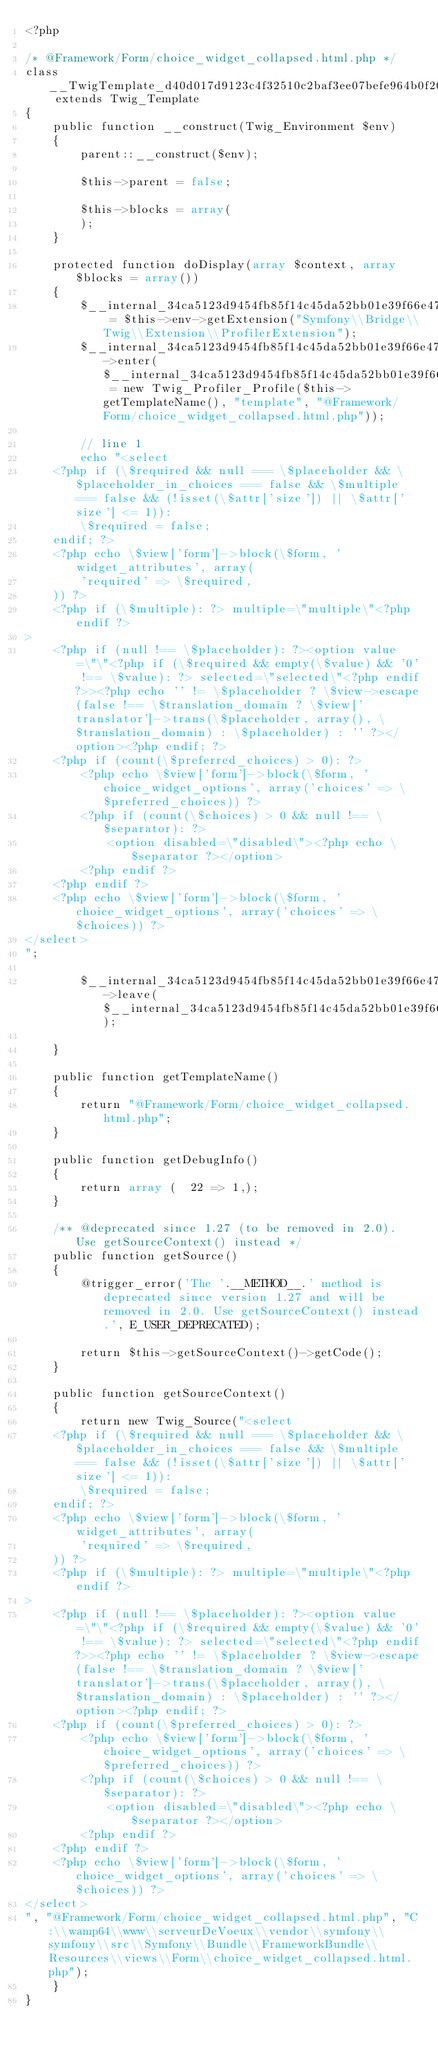<code> <loc_0><loc_0><loc_500><loc_500><_PHP_><?php

/* @Framework/Form/choice_widget_collapsed.html.php */
class __TwigTemplate_d40d017d9123c4f32510c2baf3ee07befe964b0f20a939435dd4f6bbbf2505c4 extends Twig_Template
{
    public function __construct(Twig_Environment $env)
    {
        parent::__construct($env);

        $this->parent = false;

        $this->blocks = array(
        );
    }

    protected function doDisplay(array $context, array $blocks = array())
    {
        $__internal_34ca5123d9454fb85f14c45da52bb01e39f66e478682ad9883562f83e0ccfe22 = $this->env->getExtension("Symfony\\Bridge\\Twig\\Extension\\ProfilerExtension");
        $__internal_34ca5123d9454fb85f14c45da52bb01e39f66e478682ad9883562f83e0ccfe22->enter($__internal_34ca5123d9454fb85f14c45da52bb01e39f66e478682ad9883562f83e0ccfe22_prof = new Twig_Profiler_Profile($this->getTemplateName(), "template", "@Framework/Form/choice_widget_collapsed.html.php"));

        // line 1
        echo "<select
    <?php if (\$required && null === \$placeholder && \$placeholder_in_choices === false && \$multiple === false && (!isset(\$attr['size']) || \$attr['size'] <= 1)):
        \$required = false;
    endif; ?>
    <?php echo \$view['form']->block(\$form, 'widget_attributes', array(
        'required' => \$required,
    )) ?>
    <?php if (\$multiple): ?> multiple=\"multiple\"<?php endif ?>
>
    <?php if (null !== \$placeholder): ?><option value=\"\"<?php if (\$required && empty(\$value) && '0' !== \$value): ?> selected=\"selected\"<?php endif?>><?php echo '' != \$placeholder ? \$view->escape(false !== \$translation_domain ? \$view['translator']->trans(\$placeholder, array(), \$translation_domain) : \$placeholder) : '' ?></option><?php endif; ?>
    <?php if (count(\$preferred_choices) > 0): ?>
        <?php echo \$view['form']->block(\$form, 'choice_widget_options', array('choices' => \$preferred_choices)) ?>
        <?php if (count(\$choices) > 0 && null !== \$separator): ?>
            <option disabled=\"disabled\"><?php echo \$separator ?></option>
        <?php endif ?>
    <?php endif ?>
    <?php echo \$view['form']->block(\$form, 'choice_widget_options', array('choices' => \$choices)) ?>
</select>
";
        
        $__internal_34ca5123d9454fb85f14c45da52bb01e39f66e478682ad9883562f83e0ccfe22->leave($__internal_34ca5123d9454fb85f14c45da52bb01e39f66e478682ad9883562f83e0ccfe22_prof);

    }

    public function getTemplateName()
    {
        return "@Framework/Form/choice_widget_collapsed.html.php";
    }

    public function getDebugInfo()
    {
        return array (  22 => 1,);
    }

    /** @deprecated since 1.27 (to be removed in 2.0). Use getSourceContext() instead */
    public function getSource()
    {
        @trigger_error('The '.__METHOD__.' method is deprecated since version 1.27 and will be removed in 2.0. Use getSourceContext() instead.', E_USER_DEPRECATED);

        return $this->getSourceContext()->getCode();
    }

    public function getSourceContext()
    {
        return new Twig_Source("<select
    <?php if (\$required && null === \$placeholder && \$placeholder_in_choices === false && \$multiple === false && (!isset(\$attr['size']) || \$attr['size'] <= 1)):
        \$required = false;
    endif; ?>
    <?php echo \$view['form']->block(\$form, 'widget_attributes', array(
        'required' => \$required,
    )) ?>
    <?php if (\$multiple): ?> multiple=\"multiple\"<?php endif ?>
>
    <?php if (null !== \$placeholder): ?><option value=\"\"<?php if (\$required && empty(\$value) && '0' !== \$value): ?> selected=\"selected\"<?php endif?>><?php echo '' != \$placeholder ? \$view->escape(false !== \$translation_domain ? \$view['translator']->trans(\$placeholder, array(), \$translation_domain) : \$placeholder) : '' ?></option><?php endif; ?>
    <?php if (count(\$preferred_choices) > 0): ?>
        <?php echo \$view['form']->block(\$form, 'choice_widget_options', array('choices' => \$preferred_choices)) ?>
        <?php if (count(\$choices) > 0 && null !== \$separator): ?>
            <option disabled=\"disabled\"><?php echo \$separator ?></option>
        <?php endif ?>
    <?php endif ?>
    <?php echo \$view['form']->block(\$form, 'choice_widget_options', array('choices' => \$choices)) ?>
</select>
", "@Framework/Form/choice_widget_collapsed.html.php", "C:\\wamp64\\www\\serveurDeVoeux\\vendor\\symfony\\symfony\\src\\Symfony\\Bundle\\FrameworkBundle\\Resources\\views\\Form\\choice_widget_collapsed.html.php");
    }
}
</code> 